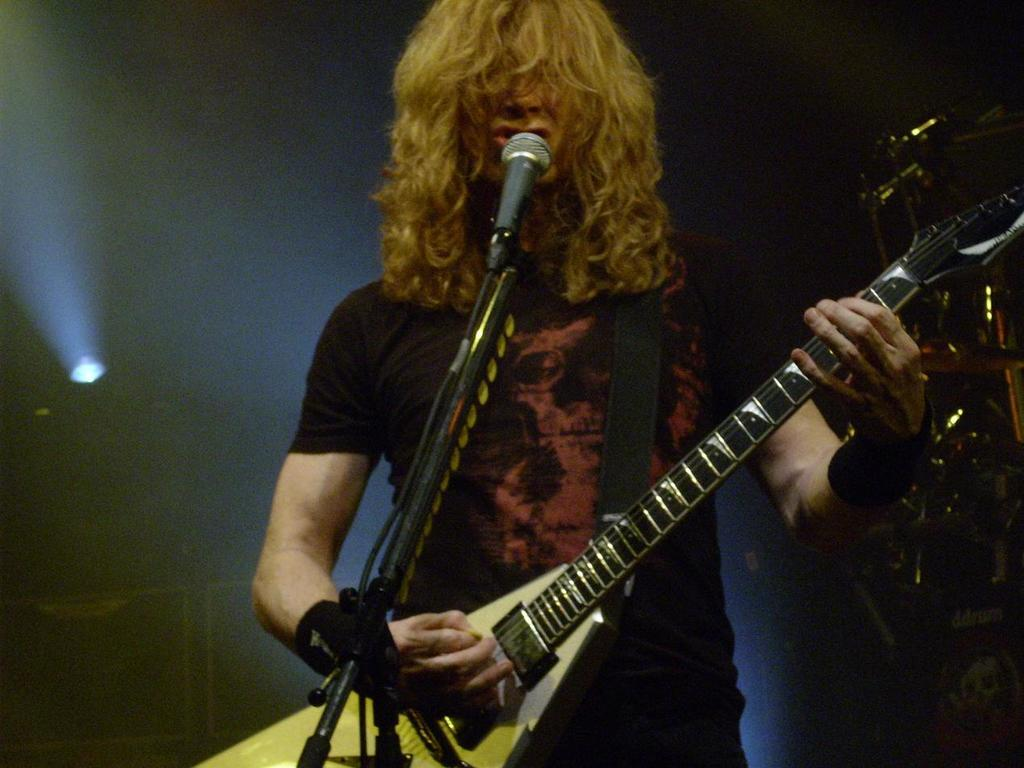What is the person in the image doing? The person is playing a guitar and singing a song. What instrument can be seen in the image? The person is playing a guitar. Where is the light located in the image? The light is on the left side of the image. What type of skin is visible on the calendar in the image? There is no calendar present in the image, and therefore no skin can be observed on it. 